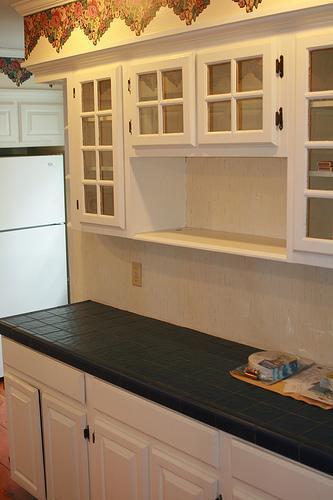How many glass cabinet doors are there?
Give a very brief answer. 4. How many large appliances are there?
Give a very brief answer. 1. 